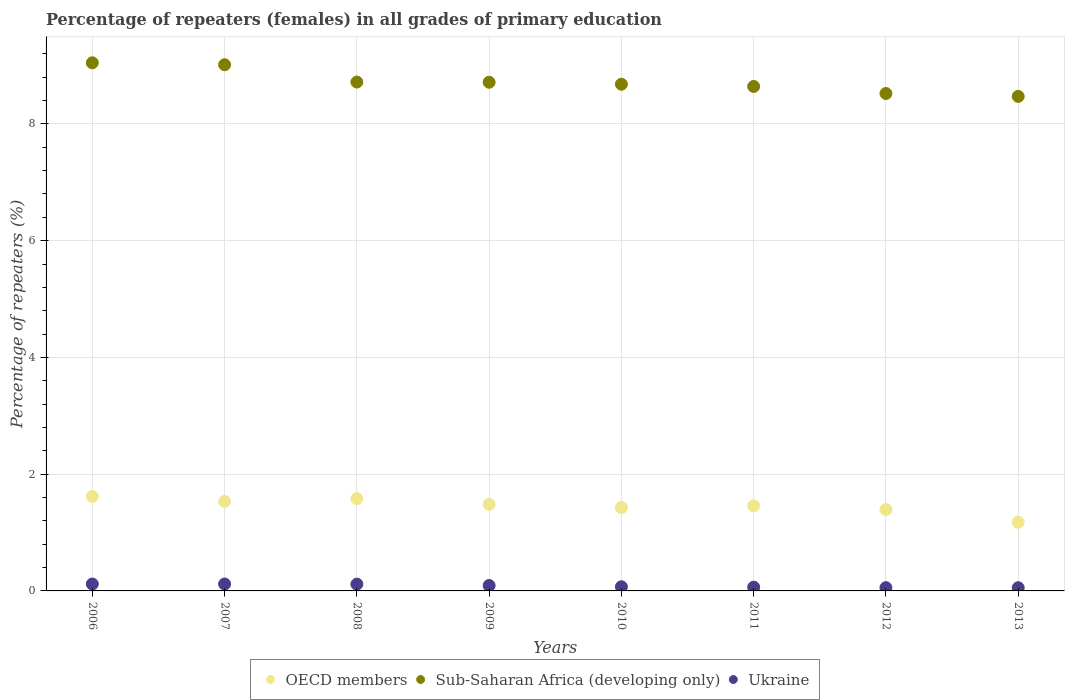How many different coloured dotlines are there?
Provide a short and direct response. 3. What is the percentage of repeaters (females) in Sub-Saharan Africa (developing only) in 2007?
Give a very brief answer. 9.01. Across all years, what is the maximum percentage of repeaters (females) in Ukraine?
Provide a succinct answer. 0.12. Across all years, what is the minimum percentage of repeaters (females) in Ukraine?
Give a very brief answer. 0.05. What is the total percentage of repeaters (females) in Sub-Saharan Africa (developing only) in the graph?
Your answer should be very brief. 69.81. What is the difference between the percentage of repeaters (females) in Ukraine in 2010 and that in 2013?
Offer a very short reply. 0.02. What is the difference between the percentage of repeaters (females) in Sub-Saharan Africa (developing only) in 2013 and the percentage of repeaters (females) in OECD members in 2007?
Keep it short and to the point. 6.94. What is the average percentage of repeaters (females) in Sub-Saharan Africa (developing only) per year?
Your answer should be compact. 8.73. In the year 2009, what is the difference between the percentage of repeaters (females) in Sub-Saharan Africa (developing only) and percentage of repeaters (females) in Ukraine?
Provide a short and direct response. 8.62. In how many years, is the percentage of repeaters (females) in Sub-Saharan Africa (developing only) greater than 8.8 %?
Keep it short and to the point. 2. What is the ratio of the percentage of repeaters (females) in Sub-Saharan Africa (developing only) in 2006 to that in 2010?
Your answer should be very brief. 1.04. Is the difference between the percentage of repeaters (females) in Sub-Saharan Africa (developing only) in 2006 and 2013 greater than the difference between the percentage of repeaters (females) in Ukraine in 2006 and 2013?
Keep it short and to the point. Yes. What is the difference between the highest and the second highest percentage of repeaters (females) in Sub-Saharan Africa (developing only)?
Ensure brevity in your answer.  0.03. What is the difference between the highest and the lowest percentage of repeaters (females) in Ukraine?
Your answer should be compact. 0.06. In how many years, is the percentage of repeaters (females) in Sub-Saharan Africa (developing only) greater than the average percentage of repeaters (females) in Sub-Saharan Africa (developing only) taken over all years?
Your answer should be compact. 2. Does the percentage of repeaters (females) in Ukraine monotonically increase over the years?
Give a very brief answer. No. Is the percentage of repeaters (females) in OECD members strictly greater than the percentage of repeaters (females) in Ukraine over the years?
Ensure brevity in your answer.  Yes. Is the percentage of repeaters (females) in OECD members strictly less than the percentage of repeaters (females) in Ukraine over the years?
Provide a succinct answer. No. How many dotlines are there?
Offer a very short reply. 3. How many years are there in the graph?
Your answer should be very brief. 8. Does the graph contain grids?
Offer a terse response. Yes. How are the legend labels stacked?
Provide a short and direct response. Horizontal. What is the title of the graph?
Provide a short and direct response. Percentage of repeaters (females) in all grades of primary education. Does "Marshall Islands" appear as one of the legend labels in the graph?
Keep it short and to the point. No. What is the label or title of the X-axis?
Your answer should be compact. Years. What is the label or title of the Y-axis?
Your response must be concise. Percentage of repeaters (%). What is the Percentage of repeaters (%) in OECD members in 2006?
Offer a terse response. 1.62. What is the Percentage of repeaters (%) of Sub-Saharan Africa (developing only) in 2006?
Provide a succinct answer. 9.05. What is the Percentage of repeaters (%) of Ukraine in 2006?
Offer a very short reply. 0.12. What is the Percentage of repeaters (%) of OECD members in 2007?
Keep it short and to the point. 1.53. What is the Percentage of repeaters (%) of Sub-Saharan Africa (developing only) in 2007?
Your response must be concise. 9.01. What is the Percentage of repeaters (%) in Ukraine in 2007?
Make the answer very short. 0.12. What is the Percentage of repeaters (%) of OECD members in 2008?
Provide a short and direct response. 1.58. What is the Percentage of repeaters (%) of Sub-Saharan Africa (developing only) in 2008?
Your answer should be compact. 8.72. What is the Percentage of repeaters (%) of Ukraine in 2008?
Give a very brief answer. 0.12. What is the Percentage of repeaters (%) in OECD members in 2009?
Your response must be concise. 1.48. What is the Percentage of repeaters (%) of Sub-Saharan Africa (developing only) in 2009?
Offer a very short reply. 8.71. What is the Percentage of repeaters (%) in Ukraine in 2009?
Offer a terse response. 0.09. What is the Percentage of repeaters (%) of OECD members in 2010?
Your response must be concise. 1.43. What is the Percentage of repeaters (%) of Sub-Saharan Africa (developing only) in 2010?
Give a very brief answer. 8.68. What is the Percentage of repeaters (%) of Ukraine in 2010?
Provide a succinct answer. 0.07. What is the Percentage of repeaters (%) of OECD members in 2011?
Offer a very short reply. 1.46. What is the Percentage of repeaters (%) in Sub-Saharan Africa (developing only) in 2011?
Provide a succinct answer. 8.64. What is the Percentage of repeaters (%) in Ukraine in 2011?
Ensure brevity in your answer.  0.06. What is the Percentage of repeaters (%) of OECD members in 2012?
Provide a short and direct response. 1.39. What is the Percentage of repeaters (%) in Sub-Saharan Africa (developing only) in 2012?
Make the answer very short. 8.52. What is the Percentage of repeaters (%) in Ukraine in 2012?
Ensure brevity in your answer.  0.06. What is the Percentage of repeaters (%) of OECD members in 2013?
Offer a terse response. 1.18. What is the Percentage of repeaters (%) of Sub-Saharan Africa (developing only) in 2013?
Give a very brief answer. 8.47. What is the Percentage of repeaters (%) in Ukraine in 2013?
Your response must be concise. 0.05. Across all years, what is the maximum Percentage of repeaters (%) in OECD members?
Offer a terse response. 1.62. Across all years, what is the maximum Percentage of repeaters (%) in Sub-Saharan Africa (developing only)?
Keep it short and to the point. 9.05. Across all years, what is the maximum Percentage of repeaters (%) in Ukraine?
Your answer should be compact. 0.12. Across all years, what is the minimum Percentage of repeaters (%) of OECD members?
Your response must be concise. 1.18. Across all years, what is the minimum Percentage of repeaters (%) in Sub-Saharan Africa (developing only)?
Keep it short and to the point. 8.47. Across all years, what is the minimum Percentage of repeaters (%) in Ukraine?
Make the answer very short. 0.05. What is the total Percentage of repeaters (%) in OECD members in the graph?
Your answer should be very brief. 11.67. What is the total Percentage of repeaters (%) in Sub-Saharan Africa (developing only) in the graph?
Offer a terse response. 69.81. What is the total Percentage of repeaters (%) of Ukraine in the graph?
Give a very brief answer. 0.69. What is the difference between the Percentage of repeaters (%) of OECD members in 2006 and that in 2007?
Provide a short and direct response. 0.09. What is the difference between the Percentage of repeaters (%) in Sub-Saharan Africa (developing only) in 2006 and that in 2007?
Your response must be concise. 0.03. What is the difference between the Percentage of repeaters (%) of Ukraine in 2006 and that in 2007?
Your answer should be compact. 0. What is the difference between the Percentage of repeaters (%) in OECD members in 2006 and that in 2008?
Provide a short and direct response. 0.04. What is the difference between the Percentage of repeaters (%) of Sub-Saharan Africa (developing only) in 2006 and that in 2008?
Keep it short and to the point. 0.33. What is the difference between the Percentage of repeaters (%) of Ukraine in 2006 and that in 2008?
Provide a succinct answer. 0. What is the difference between the Percentage of repeaters (%) of OECD members in 2006 and that in 2009?
Keep it short and to the point. 0.14. What is the difference between the Percentage of repeaters (%) of Sub-Saharan Africa (developing only) in 2006 and that in 2009?
Give a very brief answer. 0.33. What is the difference between the Percentage of repeaters (%) of Ukraine in 2006 and that in 2009?
Make the answer very short. 0.03. What is the difference between the Percentage of repeaters (%) in OECD members in 2006 and that in 2010?
Provide a succinct answer. 0.19. What is the difference between the Percentage of repeaters (%) in Sub-Saharan Africa (developing only) in 2006 and that in 2010?
Your response must be concise. 0.37. What is the difference between the Percentage of repeaters (%) in Ukraine in 2006 and that in 2010?
Provide a short and direct response. 0.05. What is the difference between the Percentage of repeaters (%) of OECD members in 2006 and that in 2011?
Keep it short and to the point. 0.16. What is the difference between the Percentage of repeaters (%) of Sub-Saharan Africa (developing only) in 2006 and that in 2011?
Give a very brief answer. 0.41. What is the difference between the Percentage of repeaters (%) in Ukraine in 2006 and that in 2011?
Keep it short and to the point. 0.05. What is the difference between the Percentage of repeaters (%) in OECD members in 2006 and that in 2012?
Your response must be concise. 0.22. What is the difference between the Percentage of repeaters (%) of Sub-Saharan Africa (developing only) in 2006 and that in 2012?
Your answer should be very brief. 0.53. What is the difference between the Percentage of repeaters (%) in Ukraine in 2006 and that in 2012?
Ensure brevity in your answer.  0.06. What is the difference between the Percentage of repeaters (%) of OECD members in 2006 and that in 2013?
Keep it short and to the point. 0.44. What is the difference between the Percentage of repeaters (%) in Sub-Saharan Africa (developing only) in 2006 and that in 2013?
Your response must be concise. 0.57. What is the difference between the Percentage of repeaters (%) of Ukraine in 2006 and that in 2013?
Your answer should be very brief. 0.06. What is the difference between the Percentage of repeaters (%) of OECD members in 2007 and that in 2008?
Your answer should be very brief. -0.05. What is the difference between the Percentage of repeaters (%) in Sub-Saharan Africa (developing only) in 2007 and that in 2008?
Keep it short and to the point. 0.3. What is the difference between the Percentage of repeaters (%) of Ukraine in 2007 and that in 2008?
Provide a short and direct response. 0. What is the difference between the Percentage of repeaters (%) in OECD members in 2007 and that in 2009?
Make the answer very short. 0.05. What is the difference between the Percentage of repeaters (%) of Sub-Saharan Africa (developing only) in 2007 and that in 2009?
Keep it short and to the point. 0.3. What is the difference between the Percentage of repeaters (%) in Ukraine in 2007 and that in 2009?
Give a very brief answer. 0.03. What is the difference between the Percentage of repeaters (%) of OECD members in 2007 and that in 2010?
Your answer should be compact. 0.1. What is the difference between the Percentage of repeaters (%) in Sub-Saharan Africa (developing only) in 2007 and that in 2010?
Offer a terse response. 0.33. What is the difference between the Percentage of repeaters (%) of Ukraine in 2007 and that in 2010?
Provide a succinct answer. 0.05. What is the difference between the Percentage of repeaters (%) in OECD members in 2007 and that in 2011?
Provide a succinct answer. 0.08. What is the difference between the Percentage of repeaters (%) of Sub-Saharan Africa (developing only) in 2007 and that in 2011?
Give a very brief answer. 0.37. What is the difference between the Percentage of repeaters (%) of Ukraine in 2007 and that in 2011?
Offer a very short reply. 0.05. What is the difference between the Percentage of repeaters (%) in OECD members in 2007 and that in 2012?
Keep it short and to the point. 0.14. What is the difference between the Percentage of repeaters (%) of Sub-Saharan Africa (developing only) in 2007 and that in 2012?
Offer a terse response. 0.49. What is the difference between the Percentage of repeaters (%) of Ukraine in 2007 and that in 2012?
Offer a very short reply. 0.06. What is the difference between the Percentage of repeaters (%) in OECD members in 2007 and that in 2013?
Provide a short and direct response. 0.36. What is the difference between the Percentage of repeaters (%) of Sub-Saharan Africa (developing only) in 2007 and that in 2013?
Your answer should be very brief. 0.54. What is the difference between the Percentage of repeaters (%) in Ukraine in 2007 and that in 2013?
Your answer should be compact. 0.06. What is the difference between the Percentage of repeaters (%) of OECD members in 2008 and that in 2009?
Keep it short and to the point. 0.1. What is the difference between the Percentage of repeaters (%) in Sub-Saharan Africa (developing only) in 2008 and that in 2009?
Provide a succinct answer. 0. What is the difference between the Percentage of repeaters (%) of Ukraine in 2008 and that in 2009?
Your response must be concise. 0.02. What is the difference between the Percentage of repeaters (%) in OECD members in 2008 and that in 2010?
Ensure brevity in your answer.  0.15. What is the difference between the Percentage of repeaters (%) in Sub-Saharan Africa (developing only) in 2008 and that in 2010?
Provide a succinct answer. 0.04. What is the difference between the Percentage of repeaters (%) in Ukraine in 2008 and that in 2010?
Provide a succinct answer. 0.05. What is the difference between the Percentage of repeaters (%) in OECD members in 2008 and that in 2011?
Ensure brevity in your answer.  0.12. What is the difference between the Percentage of repeaters (%) of Sub-Saharan Africa (developing only) in 2008 and that in 2011?
Offer a terse response. 0.08. What is the difference between the Percentage of repeaters (%) in Ukraine in 2008 and that in 2011?
Ensure brevity in your answer.  0.05. What is the difference between the Percentage of repeaters (%) in OECD members in 2008 and that in 2012?
Your answer should be very brief. 0.19. What is the difference between the Percentage of repeaters (%) in Sub-Saharan Africa (developing only) in 2008 and that in 2012?
Provide a short and direct response. 0.2. What is the difference between the Percentage of repeaters (%) of Ukraine in 2008 and that in 2012?
Ensure brevity in your answer.  0.06. What is the difference between the Percentage of repeaters (%) of OECD members in 2008 and that in 2013?
Your response must be concise. 0.4. What is the difference between the Percentage of repeaters (%) of Sub-Saharan Africa (developing only) in 2008 and that in 2013?
Give a very brief answer. 0.25. What is the difference between the Percentage of repeaters (%) in Ukraine in 2008 and that in 2013?
Provide a succinct answer. 0.06. What is the difference between the Percentage of repeaters (%) of OECD members in 2009 and that in 2010?
Make the answer very short. 0.05. What is the difference between the Percentage of repeaters (%) of Sub-Saharan Africa (developing only) in 2009 and that in 2010?
Your answer should be compact. 0.03. What is the difference between the Percentage of repeaters (%) in Ukraine in 2009 and that in 2010?
Offer a terse response. 0.02. What is the difference between the Percentage of repeaters (%) in OECD members in 2009 and that in 2011?
Provide a short and direct response. 0.02. What is the difference between the Percentage of repeaters (%) in Sub-Saharan Africa (developing only) in 2009 and that in 2011?
Keep it short and to the point. 0.07. What is the difference between the Percentage of repeaters (%) in Ukraine in 2009 and that in 2011?
Offer a terse response. 0.03. What is the difference between the Percentage of repeaters (%) in OECD members in 2009 and that in 2012?
Your answer should be compact. 0.09. What is the difference between the Percentage of repeaters (%) of Sub-Saharan Africa (developing only) in 2009 and that in 2012?
Your answer should be compact. 0.19. What is the difference between the Percentage of repeaters (%) of Ukraine in 2009 and that in 2012?
Your answer should be very brief. 0.04. What is the difference between the Percentage of repeaters (%) in OECD members in 2009 and that in 2013?
Provide a short and direct response. 0.31. What is the difference between the Percentage of repeaters (%) in Sub-Saharan Africa (developing only) in 2009 and that in 2013?
Ensure brevity in your answer.  0.24. What is the difference between the Percentage of repeaters (%) of Ukraine in 2009 and that in 2013?
Ensure brevity in your answer.  0.04. What is the difference between the Percentage of repeaters (%) in OECD members in 2010 and that in 2011?
Offer a very short reply. -0.03. What is the difference between the Percentage of repeaters (%) in Sub-Saharan Africa (developing only) in 2010 and that in 2011?
Make the answer very short. 0.04. What is the difference between the Percentage of repeaters (%) of Ukraine in 2010 and that in 2011?
Make the answer very short. 0.01. What is the difference between the Percentage of repeaters (%) of OECD members in 2010 and that in 2012?
Offer a very short reply. 0.04. What is the difference between the Percentage of repeaters (%) of Sub-Saharan Africa (developing only) in 2010 and that in 2012?
Offer a very short reply. 0.16. What is the difference between the Percentage of repeaters (%) in Ukraine in 2010 and that in 2012?
Offer a terse response. 0.02. What is the difference between the Percentage of repeaters (%) in OECD members in 2010 and that in 2013?
Provide a succinct answer. 0.25. What is the difference between the Percentage of repeaters (%) of Sub-Saharan Africa (developing only) in 2010 and that in 2013?
Offer a very short reply. 0.21. What is the difference between the Percentage of repeaters (%) in Ukraine in 2010 and that in 2013?
Give a very brief answer. 0.02. What is the difference between the Percentage of repeaters (%) of OECD members in 2011 and that in 2012?
Your response must be concise. 0.06. What is the difference between the Percentage of repeaters (%) in Sub-Saharan Africa (developing only) in 2011 and that in 2012?
Offer a very short reply. 0.12. What is the difference between the Percentage of repeaters (%) in Ukraine in 2011 and that in 2012?
Make the answer very short. 0.01. What is the difference between the Percentage of repeaters (%) of OECD members in 2011 and that in 2013?
Ensure brevity in your answer.  0.28. What is the difference between the Percentage of repeaters (%) in Sub-Saharan Africa (developing only) in 2011 and that in 2013?
Your answer should be very brief. 0.17. What is the difference between the Percentage of repeaters (%) in Ukraine in 2011 and that in 2013?
Offer a terse response. 0.01. What is the difference between the Percentage of repeaters (%) in OECD members in 2012 and that in 2013?
Your answer should be very brief. 0.22. What is the difference between the Percentage of repeaters (%) in Sub-Saharan Africa (developing only) in 2012 and that in 2013?
Your response must be concise. 0.05. What is the difference between the Percentage of repeaters (%) in OECD members in 2006 and the Percentage of repeaters (%) in Sub-Saharan Africa (developing only) in 2007?
Offer a very short reply. -7.4. What is the difference between the Percentage of repeaters (%) in OECD members in 2006 and the Percentage of repeaters (%) in Ukraine in 2007?
Provide a succinct answer. 1.5. What is the difference between the Percentage of repeaters (%) in Sub-Saharan Africa (developing only) in 2006 and the Percentage of repeaters (%) in Ukraine in 2007?
Keep it short and to the point. 8.93. What is the difference between the Percentage of repeaters (%) of OECD members in 2006 and the Percentage of repeaters (%) of Sub-Saharan Africa (developing only) in 2008?
Your answer should be compact. -7.1. What is the difference between the Percentage of repeaters (%) of OECD members in 2006 and the Percentage of repeaters (%) of Ukraine in 2008?
Your answer should be very brief. 1.5. What is the difference between the Percentage of repeaters (%) in Sub-Saharan Africa (developing only) in 2006 and the Percentage of repeaters (%) in Ukraine in 2008?
Offer a terse response. 8.93. What is the difference between the Percentage of repeaters (%) of OECD members in 2006 and the Percentage of repeaters (%) of Sub-Saharan Africa (developing only) in 2009?
Your answer should be compact. -7.1. What is the difference between the Percentage of repeaters (%) in OECD members in 2006 and the Percentage of repeaters (%) in Ukraine in 2009?
Keep it short and to the point. 1.53. What is the difference between the Percentage of repeaters (%) in Sub-Saharan Africa (developing only) in 2006 and the Percentage of repeaters (%) in Ukraine in 2009?
Offer a very short reply. 8.95. What is the difference between the Percentage of repeaters (%) in OECD members in 2006 and the Percentage of repeaters (%) in Sub-Saharan Africa (developing only) in 2010?
Give a very brief answer. -7.06. What is the difference between the Percentage of repeaters (%) of OECD members in 2006 and the Percentage of repeaters (%) of Ukraine in 2010?
Your answer should be compact. 1.55. What is the difference between the Percentage of repeaters (%) of Sub-Saharan Africa (developing only) in 2006 and the Percentage of repeaters (%) of Ukraine in 2010?
Offer a very short reply. 8.98. What is the difference between the Percentage of repeaters (%) of OECD members in 2006 and the Percentage of repeaters (%) of Sub-Saharan Africa (developing only) in 2011?
Provide a short and direct response. -7.02. What is the difference between the Percentage of repeaters (%) of OECD members in 2006 and the Percentage of repeaters (%) of Ukraine in 2011?
Ensure brevity in your answer.  1.55. What is the difference between the Percentage of repeaters (%) of Sub-Saharan Africa (developing only) in 2006 and the Percentage of repeaters (%) of Ukraine in 2011?
Your answer should be compact. 8.98. What is the difference between the Percentage of repeaters (%) in OECD members in 2006 and the Percentage of repeaters (%) in Sub-Saharan Africa (developing only) in 2012?
Your response must be concise. -6.9. What is the difference between the Percentage of repeaters (%) in OECD members in 2006 and the Percentage of repeaters (%) in Ukraine in 2012?
Offer a terse response. 1.56. What is the difference between the Percentage of repeaters (%) of Sub-Saharan Africa (developing only) in 2006 and the Percentage of repeaters (%) of Ukraine in 2012?
Offer a very short reply. 8.99. What is the difference between the Percentage of repeaters (%) in OECD members in 2006 and the Percentage of repeaters (%) in Sub-Saharan Africa (developing only) in 2013?
Keep it short and to the point. -6.85. What is the difference between the Percentage of repeaters (%) in OECD members in 2006 and the Percentage of repeaters (%) in Ukraine in 2013?
Your answer should be compact. 1.56. What is the difference between the Percentage of repeaters (%) in Sub-Saharan Africa (developing only) in 2006 and the Percentage of repeaters (%) in Ukraine in 2013?
Your answer should be very brief. 8.99. What is the difference between the Percentage of repeaters (%) in OECD members in 2007 and the Percentage of repeaters (%) in Sub-Saharan Africa (developing only) in 2008?
Make the answer very short. -7.18. What is the difference between the Percentage of repeaters (%) of OECD members in 2007 and the Percentage of repeaters (%) of Ukraine in 2008?
Offer a terse response. 1.42. What is the difference between the Percentage of repeaters (%) in Sub-Saharan Africa (developing only) in 2007 and the Percentage of repeaters (%) in Ukraine in 2008?
Your answer should be very brief. 8.9. What is the difference between the Percentage of repeaters (%) in OECD members in 2007 and the Percentage of repeaters (%) in Sub-Saharan Africa (developing only) in 2009?
Keep it short and to the point. -7.18. What is the difference between the Percentage of repeaters (%) of OECD members in 2007 and the Percentage of repeaters (%) of Ukraine in 2009?
Provide a short and direct response. 1.44. What is the difference between the Percentage of repeaters (%) in Sub-Saharan Africa (developing only) in 2007 and the Percentage of repeaters (%) in Ukraine in 2009?
Your answer should be very brief. 8.92. What is the difference between the Percentage of repeaters (%) in OECD members in 2007 and the Percentage of repeaters (%) in Sub-Saharan Africa (developing only) in 2010?
Your answer should be compact. -7.15. What is the difference between the Percentage of repeaters (%) in OECD members in 2007 and the Percentage of repeaters (%) in Ukraine in 2010?
Your response must be concise. 1.46. What is the difference between the Percentage of repeaters (%) of Sub-Saharan Africa (developing only) in 2007 and the Percentage of repeaters (%) of Ukraine in 2010?
Offer a very short reply. 8.94. What is the difference between the Percentage of repeaters (%) in OECD members in 2007 and the Percentage of repeaters (%) in Sub-Saharan Africa (developing only) in 2011?
Ensure brevity in your answer.  -7.11. What is the difference between the Percentage of repeaters (%) of OECD members in 2007 and the Percentage of repeaters (%) of Ukraine in 2011?
Offer a terse response. 1.47. What is the difference between the Percentage of repeaters (%) in Sub-Saharan Africa (developing only) in 2007 and the Percentage of repeaters (%) in Ukraine in 2011?
Offer a terse response. 8.95. What is the difference between the Percentage of repeaters (%) of OECD members in 2007 and the Percentage of repeaters (%) of Sub-Saharan Africa (developing only) in 2012?
Provide a succinct answer. -6.99. What is the difference between the Percentage of repeaters (%) in OECD members in 2007 and the Percentage of repeaters (%) in Ukraine in 2012?
Keep it short and to the point. 1.48. What is the difference between the Percentage of repeaters (%) of Sub-Saharan Africa (developing only) in 2007 and the Percentage of repeaters (%) of Ukraine in 2012?
Your answer should be compact. 8.96. What is the difference between the Percentage of repeaters (%) in OECD members in 2007 and the Percentage of repeaters (%) in Sub-Saharan Africa (developing only) in 2013?
Your answer should be compact. -6.94. What is the difference between the Percentage of repeaters (%) in OECD members in 2007 and the Percentage of repeaters (%) in Ukraine in 2013?
Provide a succinct answer. 1.48. What is the difference between the Percentage of repeaters (%) in Sub-Saharan Africa (developing only) in 2007 and the Percentage of repeaters (%) in Ukraine in 2013?
Your answer should be compact. 8.96. What is the difference between the Percentage of repeaters (%) of OECD members in 2008 and the Percentage of repeaters (%) of Sub-Saharan Africa (developing only) in 2009?
Make the answer very short. -7.13. What is the difference between the Percentage of repeaters (%) in OECD members in 2008 and the Percentage of repeaters (%) in Ukraine in 2009?
Offer a terse response. 1.49. What is the difference between the Percentage of repeaters (%) of Sub-Saharan Africa (developing only) in 2008 and the Percentage of repeaters (%) of Ukraine in 2009?
Offer a very short reply. 8.63. What is the difference between the Percentage of repeaters (%) in OECD members in 2008 and the Percentage of repeaters (%) in Sub-Saharan Africa (developing only) in 2010?
Your answer should be very brief. -7.1. What is the difference between the Percentage of repeaters (%) of OECD members in 2008 and the Percentage of repeaters (%) of Ukraine in 2010?
Provide a succinct answer. 1.51. What is the difference between the Percentage of repeaters (%) in Sub-Saharan Africa (developing only) in 2008 and the Percentage of repeaters (%) in Ukraine in 2010?
Ensure brevity in your answer.  8.65. What is the difference between the Percentage of repeaters (%) in OECD members in 2008 and the Percentage of repeaters (%) in Sub-Saharan Africa (developing only) in 2011?
Ensure brevity in your answer.  -7.06. What is the difference between the Percentage of repeaters (%) in OECD members in 2008 and the Percentage of repeaters (%) in Ukraine in 2011?
Your answer should be very brief. 1.52. What is the difference between the Percentage of repeaters (%) in Sub-Saharan Africa (developing only) in 2008 and the Percentage of repeaters (%) in Ukraine in 2011?
Your answer should be very brief. 8.65. What is the difference between the Percentage of repeaters (%) of OECD members in 2008 and the Percentage of repeaters (%) of Sub-Saharan Africa (developing only) in 2012?
Offer a very short reply. -6.94. What is the difference between the Percentage of repeaters (%) in OECD members in 2008 and the Percentage of repeaters (%) in Ukraine in 2012?
Give a very brief answer. 1.53. What is the difference between the Percentage of repeaters (%) in Sub-Saharan Africa (developing only) in 2008 and the Percentage of repeaters (%) in Ukraine in 2012?
Provide a succinct answer. 8.66. What is the difference between the Percentage of repeaters (%) in OECD members in 2008 and the Percentage of repeaters (%) in Sub-Saharan Africa (developing only) in 2013?
Your response must be concise. -6.89. What is the difference between the Percentage of repeaters (%) in OECD members in 2008 and the Percentage of repeaters (%) in Ukraine in 2013?
Give a very brief answer. 1.53. What is the difference between the Percentage of repeaters (%) of Sub-Saharan Africa (developing only) in 2008 and the Percentage of repeaters (%) of Ukraine in 2013?
Keep it short and to the point. 8.66. What is the difference between the Percentage of repeaters (%) of OECD members in 2009 and the Percentage of repeaters (%) of Sub-Saharan Africa (developing only) in 2010?
Provide a succinct answer. -7.2. What is the difference between the Percentage of repeaters (%) of OECD members in 2009 and the Percentage of repeaters (%) of Ukraine in 2010?
Your answer should be compact. 1.41. What is the difference between the Percentage of repeaters (%) in Sub-Saharan Africa (developing only) in 2009 and the Percentage of repeaters (%) in Ukraine in 2010?
Provide a short and direct response. 8.64. What is the difference between the Percentage of repeaters (%) in OECD members in 2009 and the Percentage of repeaters (%) in Sub-Saharan Africa (developing only) in 2011?
Provide a short and direct response. -7.16. What is the difference between the Percentage of repeaters (%) of OECD members in 2009 and the Percentage of repeaters (%) of Ukraine in 2011?
Keep it short and to the point. 1.42. What is the difference between the Percentage of repeaters (%) in Sub-Saharan Africa (developing only) in 2009 and the Percentage of repeaters (%) in Ukraine in 2011?
Provide a short and direct response. 8.65. What is the difference between the Percentage of repeaters (%) in OECD members in 2009 and the Percentage of repeaters (%) in Sub-Saharan Africa (developing only) in 2012?
Offer a terse response. -7.04. What is the difference between the Percentage of repeaters (%) of OECD members in 2009 and the Percentage of repeaters (%) of Ukraine in 2012?
Your answer should be compact. 1.43. What is the difference between the Percentage of repeaters (%) of Sub-Saharan Africa (developing only) in 2009 and the Percentage of repeaters (%) of Ukraine in 2012?
Your answer should be very brief. 8.66. What is the difference between the Percentage of repeaters (%) in OECD members in 2009 and the Percentage of repeaters (%) in Sub-Saharan Africa (developing only) in 2013?
Your response must be concise. -6.99. What is the difference between the Percentage of repeaters (%) in OECD members in 2009 and the Percentage of repeaters (%) in Ukraine in 2013?
Make the answer very short. 1.43. What is the difference between the Percentage of repeaters (%) in Sub-Saharan Africa (developing only) in 2009 and the Percentage of repeaters (%) in Ukraine in 2013?
Provide a succinct answer. 8.66. What is the difference between the Percentage of repeaters (%) of OECD members in 2010 and the Percentage of repeaters (%) of Sub-Saharan Africa (developing only) in 2011?
Provide a succinct answer. -7.21. What is the difference between the Percentage of repeaters (%) in OECD members in 2010 and the Percentage of repeaters (%) in Ukraine in 2011?
Provide a short and direct response. 1.37. What is the difference between the Percentage of repeaters (%) of Sub-Saharan Africa (developing only) in 2010 and the Percentage of repeaters (%) of Ukraine in 2011?
Your response must be concise. 8.62. What is the difference between the Percentage of repeaters (%) of OECD members in 2010 and the Percentage of repeaters (%) of Sub-Saharan Africa (developing only) in 2012?
Offer a very short reply. -7.09. What is the difference between the Percentage of repeaters (%) in OECD members in 2010 and the Percentage of repeaters (%) in Ukraine in 2012?
Your answer should be compact. 1.37. What is the difference between the Percentage of repeaters (%) of Sub-Saharan Africa (developing only) in 2010 and the Percentage of repeaters (%) of Ukraine in 2012?
Provide a short and direct response. 8.63. What is the difference between the Percentage of repeaters (%) of OECD members in 2010 and the Percentage of repeaters (%) of Sub-Saharan Africa (developing only) in 2013?
Your answer should be compact. -7.04. What is the difference between the Percentage of repeaters (%) in OECD members in 2010 and the Percentage of repeaters (%) in Ukraine in 2013?
Give a very brief answer. 1.37. What is the difference between the Percentage of repeaters (%) of Sub-Saharan Africa (developing only) in 2010 and the Percentage of repeaters (%) of Ukraine in 2013?
Offer a terse response. 8.63. What is the difference between the Percentage of repeaters (%) of OECD members in 2011 and the Percentage of repeaters (%) of Sub-Saharan Africa (developing only) in 2012?
Provide a short and direct response. -7.06. What is the difference between the Percentage of repeaters (%) of OECD members in 2011 and the Percentage of repeaters (%) of Ukraine in 2012?
Offer a terse response. 1.4. What is the difference between the Percentage of repeaters (%) of Sub-Saharan Africa (developing only) in 2011 and the Percentage of repeaters (%) of Ukraine in 2012?
Give a very brief answer. 8.59. What is the difference between the Percentage of repeaters (%) in OECD members in 2011 and the Percentage of repeaters (%) in Sub-Saharan Africa (developing only) in 2013?
Offer a terse response. -7.01. What is the difference between the Percentage of repeaters (%) of OECD members in 2011 and the Percentage of repeaters (%) of Ukraine in 2013?
Provide a succinct answer. 1.4. What is the difference between the Percentage of repeaters (%) in Sub-Saharan Africa (developing only) in 2011 and the Percentage of repeaters (%) in Ukraine in 2013?
Provide a succinct answer. 8.59. What is the difference between the Percentage of repeaters (%) of OECD members in 2012 and the Percentage of repeaters (%) of Sub-Saharan Africa (developing only) in 2013?
Keep it short and to the point. -7.08. What is the difference between the Percentage of repeaters (%) in OECD members in 2012 and the Percentage of repeaters (%) in Ukraine in 2013?
Give a very brief answer. 1.34. What is the difference between the Percentage of repeaters (%) in Sub-Saharan Africa (developing only) in 2012 and the Percentage of repeaters (%) in Ukraine in 2013?
Your answer should be very brief. 8.47. What is the average Percentage of repeaters (%) in OECD members per year?
Make the answer very short. 1.46. What is the average Percentage of repeaters (%) of Sub-Saharan Africa (developing only) per year?
Keep it short and to the point. 8.73. What is the average Percentage of repeaters (%) of Ukraine per year?
Ensure brevity in your answer.  0.09. In the year 2006, what is the difference between the Percentage of repeaters (%) of OECD members and Percentage of repeaters (%) of Sub-Saharan Africa (developing only)?
Give a very brief answer. -7.43. In the year 2006, what is the difference between the Percentage of repeaters (%) in OECD members and Percentage of repeaters (%) in Ukraine?
Provide a short and direct response. 1.5. In the year 2006, what is the difference between the Percentage of repeaters (%) in Sub-Saharan Africa (developing only) and Percentage of repeaters (%) in Ukraine?
Your response must be concise. 8.93. In the year 2007, what is the difference between the Percentage of repeaters (%) in OECD members and Percentage of repeaters (%) in Sub-Saharan Africa (developing only)?
Offer a terse response. -7.48. In the year 2007, what is the difference between the Percentage of repeaters (%) in OECD members and Percentage of repeaters (%) in Ukraine?
Offer a very short reply. 1.42. In the year 2007, what is the difference between the Percentage of repeaters (%) of Sub-Saharan Africa (developing only) and Percentage of repeaters (%) of Ukraine?
Make the answer very short. 8.9. In the year 2008, what is the difference between the Percentage of repeaters (%) in OECD members and Percentage of repeaters (%) in Sub-Saharan Africa (developing only)?
Provide a short and direct response. -7.14. In the year 2008, what is the difference between the Percentage of repeaters (%) of OECD members and Percentage of repeaters (%) of Ukraine?
Offer a terse response. 1.46. In the year 2008, what is the difference between the Percentage of repeaters (%) in Sub-Saharan Africa (developing only) and Percentage of repeaters (%) in Ukraine?
Your response must be concise. 8.6. In the year 2009, what is the difference between the Percentage of repeaters (%) of OECD members and Percentage of repeaters (%) of Sub-Saharan Africa (developing only)?
Offer a terse response. -7.23. In the year 2009, what is the difference between the Percentage of repeaters (%) of OECD members and Percentage of repeaters (%) of Ukraine?
Provide a short and direct response. 1.39. In the year 2009, what is the difference between the Percentage of repeaters (%) in Sub-Saharan Africa (developing only) and Percentage of repeaters (%) in Ukraine?
Keep it short and to the point. 8.62. In the year 2010, what is the difference between the Percentage of repeaters (%) in OECD members and Percentage of repeaters (%) in Sub-Saharan Africa (developing only)?
Your answer should be very brief. -7.25. In the year 2010, what is the difference between the Percentage of repeaters (%) of OECD members and Percentage of repeaters (%) of Ukraine?
Ensure brevity in your answer.  1.36. In the year 2010, what is the difference between the Percentage of repeaters (%) in Sub-Saharan Africa (developing only) and Percentage of repeaters (%) in Ukraine?
Keep it short and to the point. 8.61. In the year 2011, what is the difference between the Percentage of repeaters (%) in OECD members and Percentage of repeaters (%) in Sub-Saharan Africa (developing only)?
Your answer should be compact. -7.18. In the year 2011, what is the difference between the Percentage of repeaters (%) in OECD members and Percentage of repeaters (%) in Ukraine?
Give a very brief answer. 1.39. In the year 2011, what is the difference between the Percentage of repeaters (%) in Sub-Saharan Africa (developing only) and Percentage of repeaters (%) in Ukraine?
Keep it short and to the point. 8.58. In the year 2012, what is the difference between the Percentage of repeaters (%) of OECD members and Percentage of repeaters (%) of Sub-Saharan Africa (developing only)?
Provide a short and direct response. -7.13. In the year 2012, what is the difference between the Percentage of repeaters (%) of OECD members and Percentage of repeaters (%) of Ukraine?
Provide a succinct answer. 1.34. In the year 2012, what is the difference between the Percentage of repeaters (%) in Sub-Saharan Africa (developing only) and Percentage of repeaters (%) in Ukraine?
Offer a very short reply. 8.47. In the year 2013, what is the difference between the Percentage of repeaters (%) in OECD members and Percentage of repeaters (%) in Sub-Saharan Africa (developing only)?
Provide a succinct answer. -7.3. In the year 2013, what is the difference between the Percentage of repeaters (%) in OECD members and Percentage of repeaters (%) in Ukraine?
Provide a succinct answer. 1.12. In the year 2013, what is the difference between the Percentage of repeaters (%) in Sub-Saharan Africa (developing only) and Percentage of repeaters (%) in Ukraine?
Ensure brevity in your answer.  8.42. What is the ratio of the Percentage of repeaters (%) of OECD members in 2006 to that in 2007?
Your response must be concise. 1.06. What is the ratio of the Percentage of repeaters (%) in Sub-Saharan Africa (developing only) in 2006 to that in 2007?
Your answer should be compact. 1. What is the ratio of the Percentage of repeaters (%) in OECD members in 2006 to that in 2008?
Your answer should be very brief. 1.02. What is the ratio of the Percentage of repeaters (%) in Sub-Saharan Africa (developing only) in 2006 to that in 2008?
Offer a terse response. 1.04. What is the ratio of the Percentage of repeaters (%) in Ukraine in 2006 to that in 2008?
Give a very brief answer. 1.02. What is the ratio of the Percentage of repeaters (%) in OECD members in 2006 to that in 2009?
Offer a very short reply. 1.09. What is the ratio of the Percentage of repeaters (%) of Sub-Saharan Africa (developing only) in 2006 to that in 2009?
Ensure brevity in your answer.  1.04. What is the ratio of the Percentage of repeaters (%) in Ukraine in 2006 to that in 2009?
Give a very brief answer. 1.28. What is the ratio of the Percentage of repeaters (%) of OECD members in 2006 to that in 2010?
Your response must be concise. 1.13. What is the ratio of the Percentage of repeaters (%) of Sub-Saharan Africa (developing only) in 2006 to that in 2010?
Ensure brevity in your answer.  1.04. What is the ratio of the Percentage of repeaters (%) of Ukraine in 2006 to that in 2010?
Ensure brevity in your answer.  1.67. What is the ratio of the Percentage of repeaters (%) of OECD members in 2006 to that in 2011?
Provide a short and direct response. 1.11. What is the ratio of the Percentage of repeaters (%) of Sub-Saharan Africa (developing only) in 2006 to that in 2011?
Provide a short and direct response. 1.05. What is the ratio of the Percentage of repeaters (%) in Ukraine in 2006 to that in 2011?
Your answer should be compact. 1.85. What is the ratio of the Percentage of repeaters (%) of OECD members in 2006 to that in 2012?
Your answer should be compact. 1.16. What is the ratio of the Percentage of repeaters (%) in Sub-Saharan Africa (developing only) in 2006 to that in 2012?
Provide a succinct answer. 1.06. What is the ratio of the Percentage of repeaters (%) in Ukraine in 2006 to that in 2012?
Make the answer very short. 2.13. What is the ratio of the Percentage of repeaters (%) in OECD members in 2006 to that in 2013?
Your response must be concise. 1.38. What is the ratio of the Percentage of repeaters (%) in Sub-Saharan Africa (developing only) in 2006 to that in 2013?
Offer a terse response. 1.07. What is the ratio of the Percentage of repeaters (%) in Ukraine in 2006 to that in 2013?
Offer a very short reply. 2.17. What is the ratio of the Percentage of repeaters (%) in OECD members in 2007 to that in 2008?
Offer a terse response. 0.97. What is the ratio of the Percentage of repeaters (%) in Sub-Saharan Africa (developing only) in 2007 to that in 2008?
Your answer should be very brief. 1.03. What is the ratio of the Percentage of repeaters (%) in OECD members in 2007 to that in 2009?
Your answer should be very brief. 1.03. What is the ratio of the Percentage of repeaters (%) in Sub-Saharan Africa (developing only) in 2007 to that in 2009?
Your answer should be compact. 1.03. What is the ratio of the Percentage of repeaters (%) in Ukraine in 2007 to that in 2009?
Your answer should be compact. 1.28. What is the ratio of the Percentage of repeaters (%) in OECD members in 2007 to that in 2010?
Offer a very short reply. 1.07. What is the ratio of the Percentage of repeaters (%) in Sub-Saharan Africa (developing only) in 2007 to that in 2010?
Give a very brief answer. 1.04. What is the ratio of the Percentage of repeaters (%) in Ukraine in 2007 to that in 2010?
Provide a succinct answer. 1.67. What is the ratio of the Percentage of repeaters (%) in OECD members in 2007 to that in 2011?
Offer a very short reply. 1.05. What is the ratio of the Percentage of repeaters (%) in Sub-Saharan Africa (developing only) in 2007 to that in 2011?
Make the answer very short. 1.04. What is the ratio of the Percentage of repeaters (%) of Ukraine in 2007 to that in 2011?
Offer a terse response. 1.85. What is the ratio of the Percentage of repeaters (%) of OECD members in 2007 to that in 2012?
Offer a very short reply. 1.1. What is the ratio of the Percentage of repeaters (%) of Sub-Saharan Africa (developing only) in 2007 to that in 2012?
Your answer should be compact. 1.06. What is the ratio of the Percentage of repeaters (%) of Ukraine in 2007 to that in 2012?
Provide a short and direct response. 2.13. What is the ratio of the Percentage of repeaters (%) of OECD members in 2007 to that in 2013?
Keep it short and to the point. 1.3. What is the ratio of the Percentage of repeaters (%) of Sub-Saharan Africa (developing only) in 2007 to that in 2013?
Provide a succinct answer. 1.06. What is the ratio of the Percentage of repeaters (%) of Ukraine in 2007 to that in 2013?
Ensure brevity in your answer.  2.16. What is the ratio of the Percentage of repeaters (%) of OECD members in 2008 to that in 2009?
Provide a succinct answer. 1.07. What is the ratio of the Percentage of repeaters (%) of Sub-Saharan Africa (developing only) in 2008 to that in 2009?
Provide a short and direct response. 1. What is the ratio of the Percentage of repeaters (%) in Ukraine in 2008 to that in 2009?
Provide a short and direct response. 1.26. What is the ratio of the Percentage of repeaters (%) in OECD members in 2008 to that in 2010?
Ensure brevity in your answer.  1.11. What is the ratio of the Percentage of repeaters (%) of Sub-Saharan Africa (developing only) in 2008 to that in 2010?
Your answer should be compact. 1. What is the ratio of the Percentage of repeaters (%) of Ukraine in 2008 to that in 2010?
Ensure brevity in your answer.  1.64. What is the ratio of the Percentage of repeaters (%) of OECD members in 2008 to that in 2011?
Give a very brief answer. 1.08. What is the ratio of the Percentage of repeaters (%) in Sub-Saharan Africa (developing only) in 2008 to that in 2011?
Give a very brief answer. 1.01. What is the ratio of the Percentage of repeaters (%) of Ukraine in 2008 to that in 2011?
Your response must be concise. 1.82. What is the ratio of the Percentage of repeaters (%) in OECD members in 2008 to that in 2012?
Offer a terse response. 1.13. What is the ratio of the Percentage of repeaters (%) in Sub-Saharan Africa (developing only) in 2008 to that in 2012?
Provide a succinct answer. 1.02. What is the ratio of the Percentage of repeaters (%) of Ukraine in 2008 to that in 2012?
Make the answer very short. 2.09. What is the ratio of the Percentage of repeaters (%) of OECD members in 2008 to that in 2013?
Your answer should be very brief. 1.34. What is the ratio of the Percentage of repeaters (%) in Ukraine in 2008 to that in 2013?
Provide a short and direct response. 2.13. What is the ratio of the Percentage of repeaters (%) in OECD members in 2009 to that in 2010?
Your response must be concise. 1.04. What is the ratio of the Percentage of repeaters (%) in Sub-Saharan Africa (developing only) in 2009 to that in 2010?
Offer a terse response. 1. What is the ratio of the Percentage of repeaters (%) in Ukraine in 2009 to that in 2010?
Your answer should be very brief. 1.3. What is the ratio of the Percentage of repeaters (%) in OECD members in 2009 to that in 2011?
Provide a succinct answer. 1.02. What is the ratio of the Percentage of repeaters (%) of Sub-Saharan Africa (developing only) in 2009 to that in 2011?
Provide a short and direct response. 1.01. What is the ratio of the Percentage of repeaters (%) in Ukraine in 2009 to that in 2011?
Keep it short and to the point. 1.45. What is the ratio of the Percentage of repeaters (%) of OECD members in 2009 to that in 2012?
Make the answer very short. 1.06. What is the ratio of the Percentage of repeaters (%) in Sub-Saharan Africa (developing only) in 2009 to that in 2012?
Ensure brevity in your answer.  1.02. What is the ratio of the Percentage of repeaters (%) of Ukraine in 2009 to that in 2012?
Provide a short and direct response. 1.66. What is the ratio of the Percentage of repeaters (%) in OECD members in 2009 to that in 2013?
Offer a terse response. 1.26. What is the ratio of the Percentage of repeaters (%) of Sub-Saharan Africa (developing only) in 2009 to that in 2013?
Offer a terse response. 1.03. What is the ratio of the Percentage of repeaters (%) of Ukraine in 2009 to that in 2013?
Offer a terse response. 1.69. What is the ratio of the Percentage of repeaters (%) of OECD members in 2010 to that in 2011?
Your answer should be very brief. 0.98. What is the ratio of the Percentage of repeaters (%) of Ukraine in 2010 to that in 2011?
Your response must be concise. 1.11. What is the ratio of the Percentage of repeaters (%) of OECD members in 2010 to that in 2012?
Provide a succinct answer. 1.03. What is the ratio of the Percentage of repeaters (%) in Sub-Saharan Africa (developing only) in 2010 to that in 2012?
Ensure brevity in your answer.  1.02. What is the ratio of the Percentage of repeaters (%) in Ukraine in 2010 to that in 2012?
Ensure brevity in your answer.  1.27. What is the ratio of the Percentage of repeaters (%) in OECD members in 2010 to that in 2013?
Your response must be concise. 1.21. What is the ratio of the Percentage of repeaters (%) in Sub-Saharan Africa (developing only) in 2010 to that in 2013?
Keep it short and to the point. 1.02. What is the ratio of the Percentage of repeaters (%) in Ukraine in 2010 to that in 2013?
Offer a terse response. 1.3. What is the ratio of the Percentage of repeaters (%) in OECD members in 2011 to that in 2012?
Your answer should be very brief. 1.05. What is the ratio of the Percentage of repeaters (%) in Sub-Saharan Africa (developing only) in 2011 to that in 2012?
Keep it short and to the point. 1.01. What is the ratio of the Percentage of repeaters (%) in Ukraine in 2011 to that in 2012?
Give a very brief answer. 1.15. What is the ratio of the Percentage of repeaters (%) in OECD members in 2011 to that in 2013?
Ensure brevity in your answer.  1.24. What is the ratio of the Percentage of repeaters (%) of Sub-Saharan Africa (developing only) in 2011 to that in 2013?
Your response must be concise. 1.02. What is the ratio of the Percentage of repeaters (%) in Ukraine in 2011 to that in 2013?
Your answer should be compact. 1.17. What is the ratio of the Percentage of repeaters (%) of OECD members in 2012 to that in 2013?
Give a very brief answer. 1.18. What is the ratio of the Percentage of repeaters (%) of Ukraine in 2012 to that in 2013?
Your answer should be very brief. 1.02. What is the difference between the highest and the second highest Percentage of repeaters (%) of OECD members?
Your answer should be compact. 0.04. What is the difference between the highest and the second highest Percentage of repeaters (%) of Sub-Saharan Africa (developing only)?
Your response must be concise. 0.03. What is the difference between the highest and the second highest Percentage of repeaters (%) in Ukraine?
Keep it short and to the point. 0. What is the difference between the highest and the lowest Percentage of repeaters (%) in OECD members?
Your answer should be very brief. 0.44. What is the difference between the highest and the lowest Percentage of repeaters (%) in Sub-Saharan Africa (developing only)?
Offer a very short reply. 0.57. What is the difference between the highest and the lowest Percentage of repeaters (%) of Ukraine?
Offer a terse response. 0.06. 